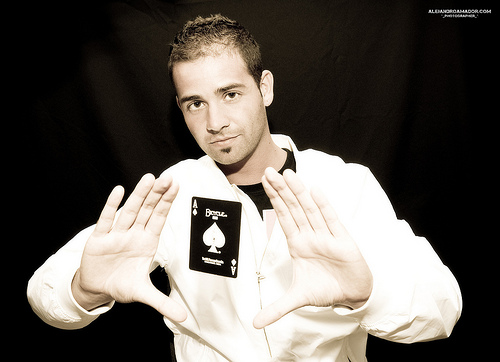<image>
Is the playing card next to the shirt? No. The playing card is not positioned next to the shirt. They are located in different areas of the scene. 